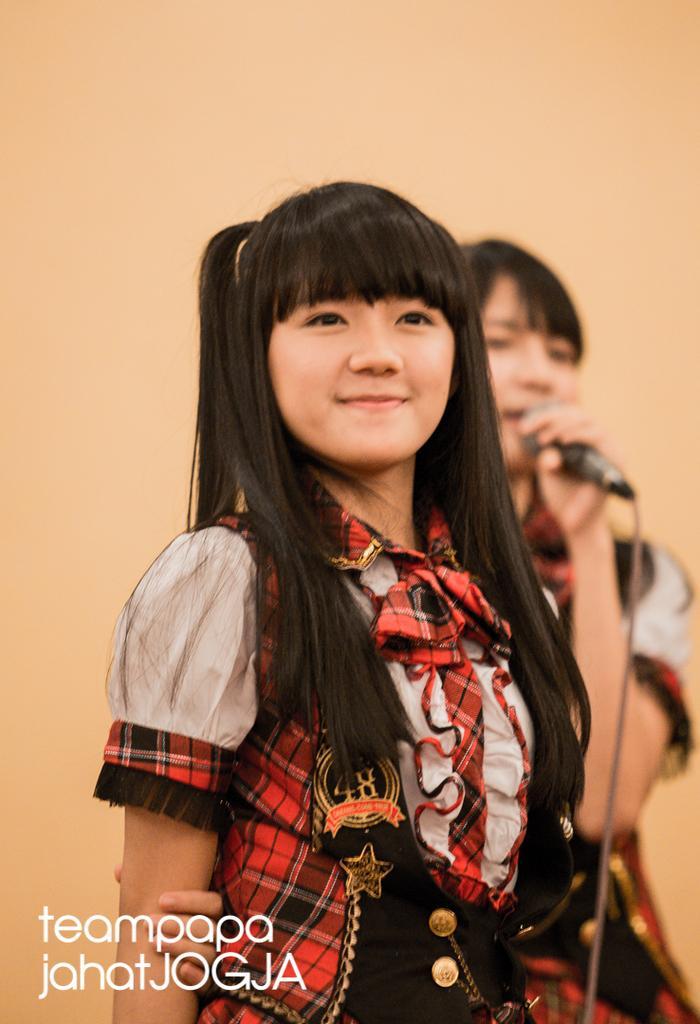Please provide a concise description of this image. In the foreground of this image, there is a woman standing in red and black dress having smile on her face. In the background, there is an another woman holding a mic in her hand and a creamy background. 